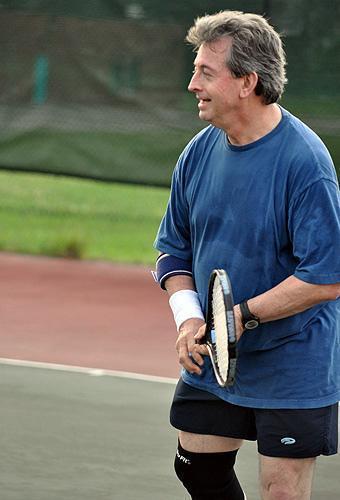How many statues on the clock have wings?
Give a very brief answer. 0. 